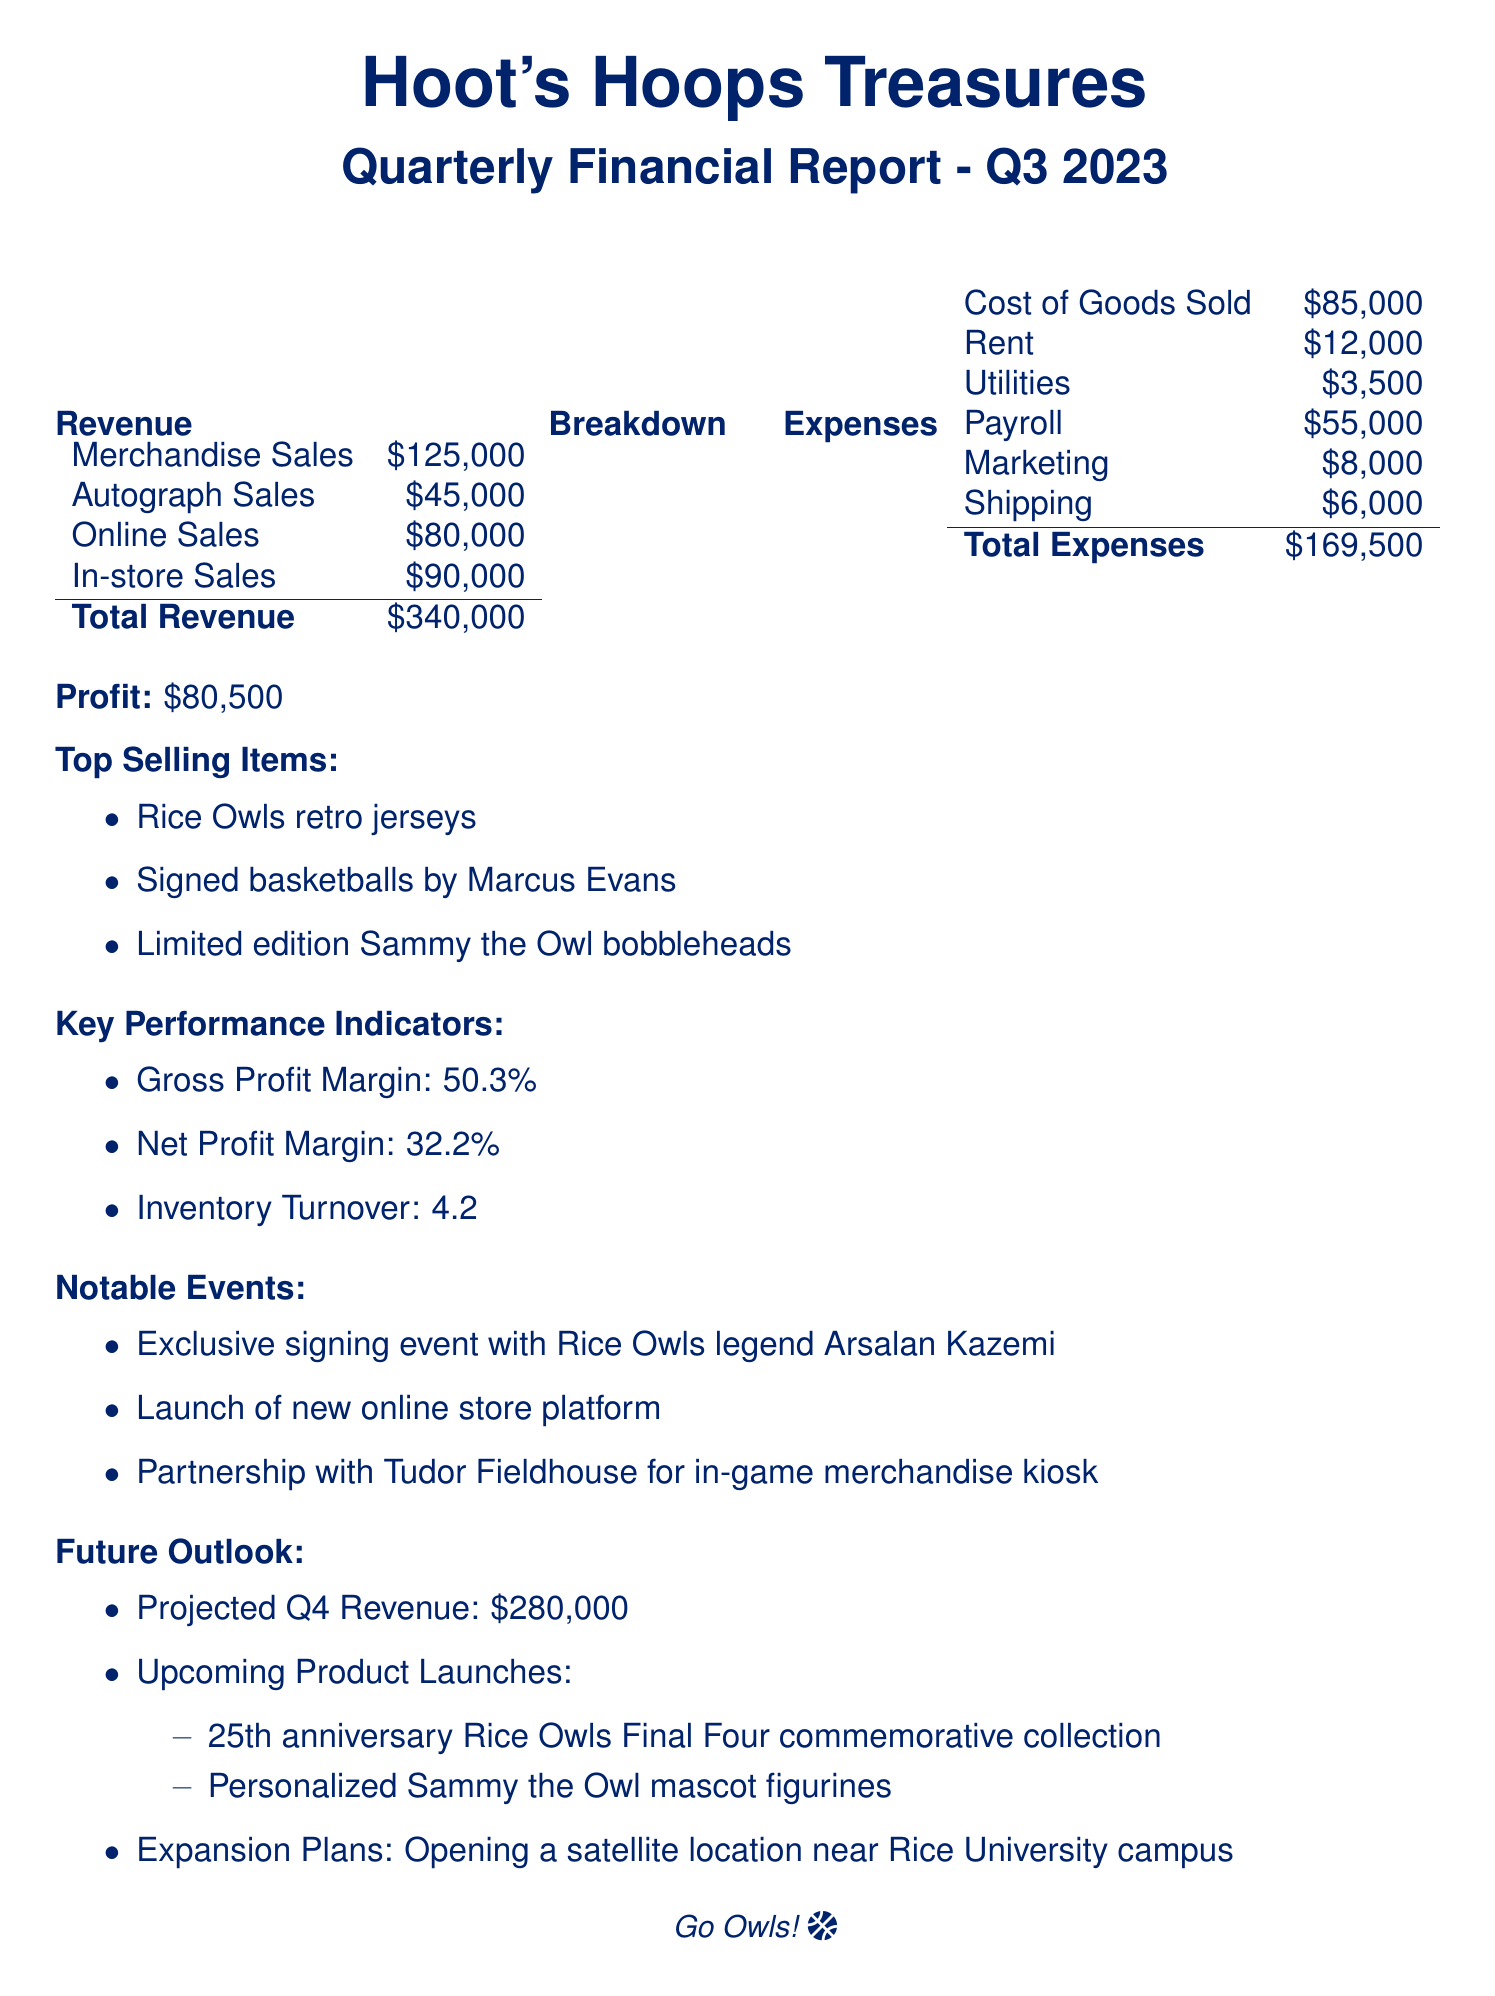What is the total revenue? The total revenue is the sum of merchandise sales, autograph sales, online sales, and in-store sales, which equals $125,000 + $45,000 + $80,000 + $90,000 = $340,000.
Answer: $340,000 What was the profit for Q3 2023? The profit is explicitly stated in the document as $80,500.
Answer: $80,500 Which Rice Owls items are the top sellers? The document lists the three top-selling items as Rice Owls retro jerseys, signed basketballs by Marcus Evans, and limited edition Sammy the Owl bobbleheads.
Answer: Rice Owls retro jerseys, signed basketballs by Marcus Evans, limited edition Sammy the Owl bobbleheads What is the gross profit margin? The gross profit margin is specified in the key performance indicators section of the document as 50.3%.
Answer: 50.3% What event featured a signing with a Rice Owls legend? The document mentions an exclusive signing event with Rice Owls legend Arsalan Kazemi.
Answer: Arsalan Kazemi What are the projected Q4 revenues? The projected Q4 revenue is forecasted in the future outlook section as $280,000.
Answer: $280,000 How many product launches are being planned? The document outlines two upcoming product launches in the future outlook.
Answer: Two What are the expansion plans for Hoot's Hoops Treasures? The document states that there are plans to open a satellite location near the Rice University campus.
Answer: Opening a satellite location near Rice University campus What was the marketing expense? The marketing expense is listed in the expenses section as $8,000.
Answer: $8,000 